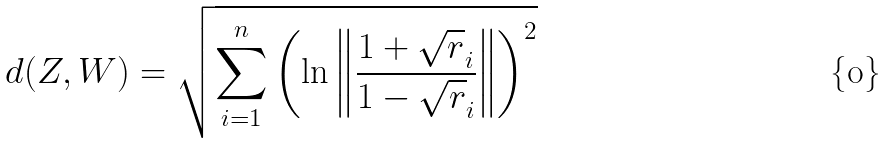<formula> <loc_0><loc_0><loc_500><loc_500>d ( Z , W ) = \sqrt { \sum _ { i = 1 } ^ { n } \left ( \ln \left \| \frac { 1 + \sqrt { r } _ { i } } { 1 - \sqrt { r } _ { i } } \right \| \right ) ^ { 2 } }</formula> 